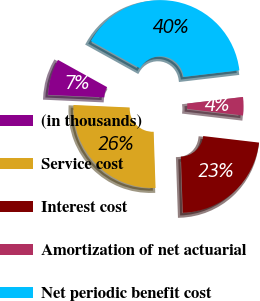Convert chart. <chart><loc_0><loc_0><loc_500><loc_500><pie_chart><fcel>(in thousands)<fcel>Service cost<fcel>Interest cost<fcel>Amortization of net actuarial<fcel>Net periodic benefit cost<nl><fcel>7.35%<fcel>26.25%<fcel>22.61%<fcel>3.72%<fcel>40.07%<nl></chart> 